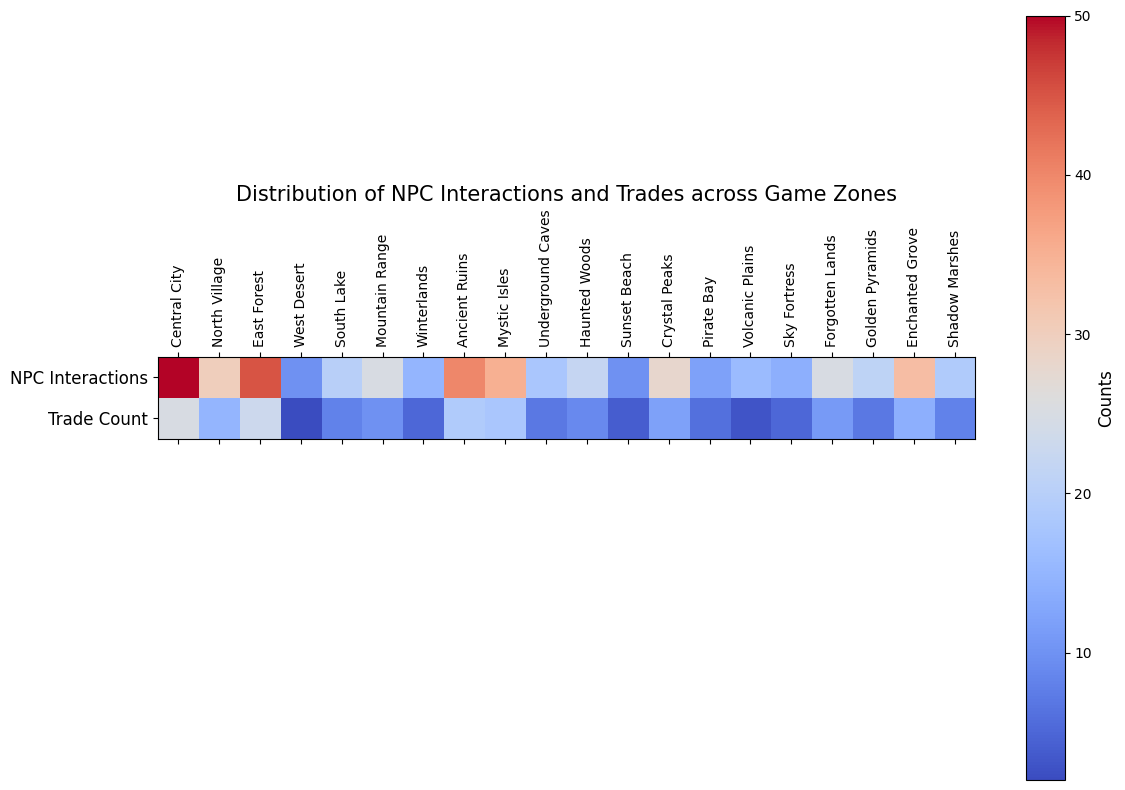What zone has the highest number of NPC interactions? The heatmap's row labeled 'NPC Interactions' indicates the counts of interactions for each zone. The highest value is located in the 'Central City' cell.
Answer: Central City Which zone has a higher trade count, East Forest or Mystic Isles? By comparing the 'Trade Count' row in the heatmap for East Forest and Mystic Isles, the trade count for East Forest is 23, whereas for Mystic Isles it is 18.
Answer: East Forest What is the total number of NPC interactions across Central City and East Forest? Refer to the 'NPC Interactions' row for Central City and East Forest, which are 50 and 45 respectively. Adding these values, 50 + 45 = 95.
Answer: 95 Are there any zones with both NPC interactions and trade count less than 10? Checking both rows, 'NPC Interactions' and 'Trade Count', the cell values for 'West Desert' (10, 2) and 'Volcanic Plains' (16, 3) show that only 'West Desert' matches the condition.
Answer: West Desert Which has more zones with trade counts greater than 20, or NPC interactions greater than 40? Checking the 'Trade Count' row, only two zones (Central City and East Forest) have counts greater than 20. For 'NPC Interactions', three zones (Central City, East Forest, and Ancient Ruins) have counts greater than 40.
Answer: NPC interactions greater than 40 What is the average trade count for zones with NPC interactions greater than 30? Identify zones with 'NPC Interactions' > 30, which are Central City (50/25), East Forest (45/23), Ancient Ruins (40/19), Mystic Isles (35/18), Enchanted Grove (33/14). Their trade counts are 25, 23, 19, 18, 14. The average is (25+23+19+18+14)/5 = 99/5 = 19.8
Answer: 19.8 Is there any zone where NPC interactions are exactly double the trade count? By examining the heatmap, 'Central City' is found with 'NPC Interactions' = 50 and 'Trade Count' = 25, which is exactly double.
Answer: Central City Which zone has the least NPC interactions, and what is its trade count? The heatmap shows 'Sunset Beach' with the least 'NPC Interactions' value of 10. The corresponding 'Trade Count' is 4.
Answer: Sunset Beach, 4 